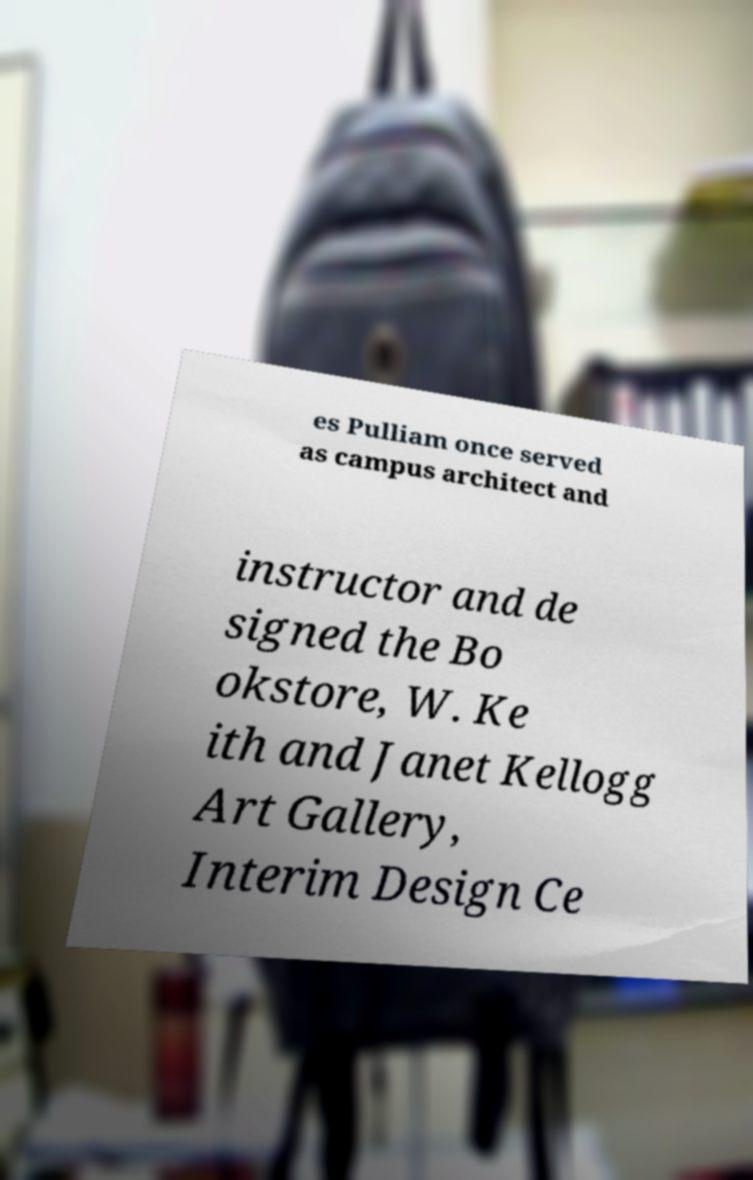Please read and relay the text visible in this image. What does it say? es Pulliam once served as campus architect and instructor and de signed the Bo okstore, W. Ke ith and Janet Kellogg Art Gallery, Interim Design Ce 